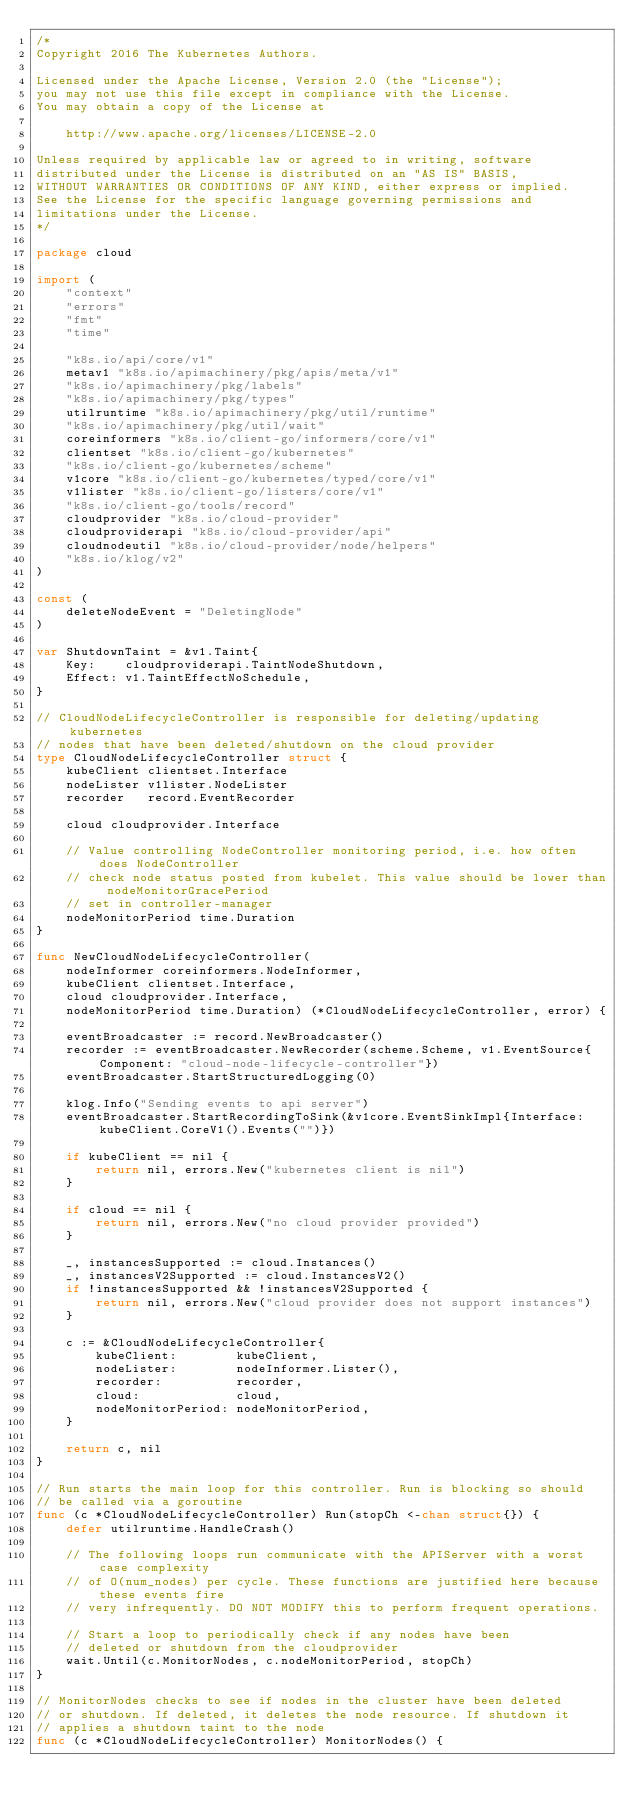Convert code to text. <code><loc_0><loc_0><loc_500><loc_500><_Go_>/*
Copyright 2016 The Kubernetes Authors.

Licensed under the Apache License, Version 2.0 (the "License");
you may not use this file except in compliance with the License.
You may obtain a copy of the License at

    http://www.apache.org/licenses/LICENSE-2.0

Unless required by applicable law or agreed to in writing, software
distributed under the License is distributed on an "AS IS" BASIS,
WITHOUT WARRANTIES OR CONDITIONS OF ANY KIND, either express or implied.
See the License for the specific language governing permissions and
limitations under the License.
*/

package cloud

import (
	"context"
	"errors"
	"fmt"
	"time"

	"k8s.io/api/core/v1"
	metav1 "k8s.io/apimachinery/pkg/apis/meta/v1"
	"k8s.io/apimachinery/pkg/labels"
	"k8s.io/apimachinery/pkg/types"
	utilruntime "k8s.io/apimachinery/pkg/util/runtime"
	"k8s.io/apimachinery/pkg/util/wait"
	coreinformers "k8s.io/client-go/informers/core/v1"
	clientset "k8s.io/client-go/kubernetes"
	"k8s.io/client-go/kubernetes/scheme"
	v1core "k8s.io/client-go/kubernetes/typed/core/v1"
	v1lister "k8s.io/client-go/listers/core/v1"
	"k8s.io/client-go/tools/record"
	cloudprovider "k8s.io/cloud-provider"
	cloudproviderapi "k8s.io/cloud-provider/api"
	cloudnodeutil "k8s.io/cloud-provider/node/helpers"
	"k8s.io/klog/v2"
)

const (
	deleteNodeEvent = "DeletingNode"
)

var ShutdownTaint = &v1.Taint{
	Key:    cloudproviderapi.TaintNodeShutdown,
	Effect: v1.TaintEffectNoSchedule,
}

// CloudNodeLifecycleController is responsible for deleting/updating kubernetes
// nodes that have been deleted/shutdown on the cloud provider
type CloudNodeLifecycleController struct {
	kubeClient clientset.Interface
	nodeLister v1lister.NodeLister
	recorder   record.EventRecorder

	cloud cloudprovider.Interface

	// Value controlling NodeController monitoring period, i.e. how often does NodeController
	// check node status posted from kubelet. This value should be lower than nodeMonitorGracePeriod
	// set in controller-manager
	nodeMonitorPeriod time.Duration
}

func NewCloudNodeLifecycleController(
	nodeInformer coreinformers.NodeInformer,
	kubeClient clientset.Interface,
	cloud cloudprovider.Interface,
	nodeMonitorPeriod time.Duration) (*CloudNodeLifecycleController, error) {

	eventBroadcaster := record.NewBroadcaster()
	recorder := eventBroadcaster.NewRecorder(scheme.Scheme, v1.EventSource{Component: "cloud-node-lifecycle-controller"})
	eventBroadcaster.StartStructuredLogging(0)

	klog.Info("Sending events to api server")
	eventBroadcaster.StartRecordingToSink(&v1core.EventSinkImpl{Interface: kubeClient.CoreV1().Events("")})

	if kubeClient == nil {
		return nil, errors.New("kubernetes client is nil")
	}

	if cloud == nil {
		return nil, errors.New("no cloud provider provided")
	}

	_, instancesSupported := cloud.Instances()
	_, instancesV2Supported := cloud.InstancesV2()
	if !instancesSupported && !instancesV2Supported {
		return nil, errors.New("cloud provider does not support instances")
	}

	c := &CloudNodeLifecycleController{
		kubeClient:        kubeClient,
		nodeLister:        nodeInformer.Lister(),
		recorder:          recorder,
		cloud:             cloud,
		nodeMonitorPeriod: nodeMonitorPeriod,
	}

	return c, nil
}

// Run starts the main loop for this controller. Run is blocking so should
// be called via a goroutine
func (c *CloudNodeLifecycleController) Run(stopCh <-chan struct{}) {
	defer utilruntime.HandleCrash()

	// The following loops run communicate with the APIServer with a worst case complexity
	// of O(num_nodes) per cycle. These functions are justified here because these events fire
	// very infrequently. DO NOT MODIFY this to perform frequent operations.

	// Start a loop to periodically check if any nodes have been
	// deleted or shutdown from the cloudprovider
	wait.Until(c.MonitorNodes, c.nodeMonitorPeriod, stopCh)
}

// MonitorNodes checks to see if nodes in the cluster have been deleted
// or shutdown. If deleted, it deletes the node resource. If shutdown it
// applies a shutdown taint to the node
func (c *CloudNodeLifecycleController) MonitorNodes() {</code> 